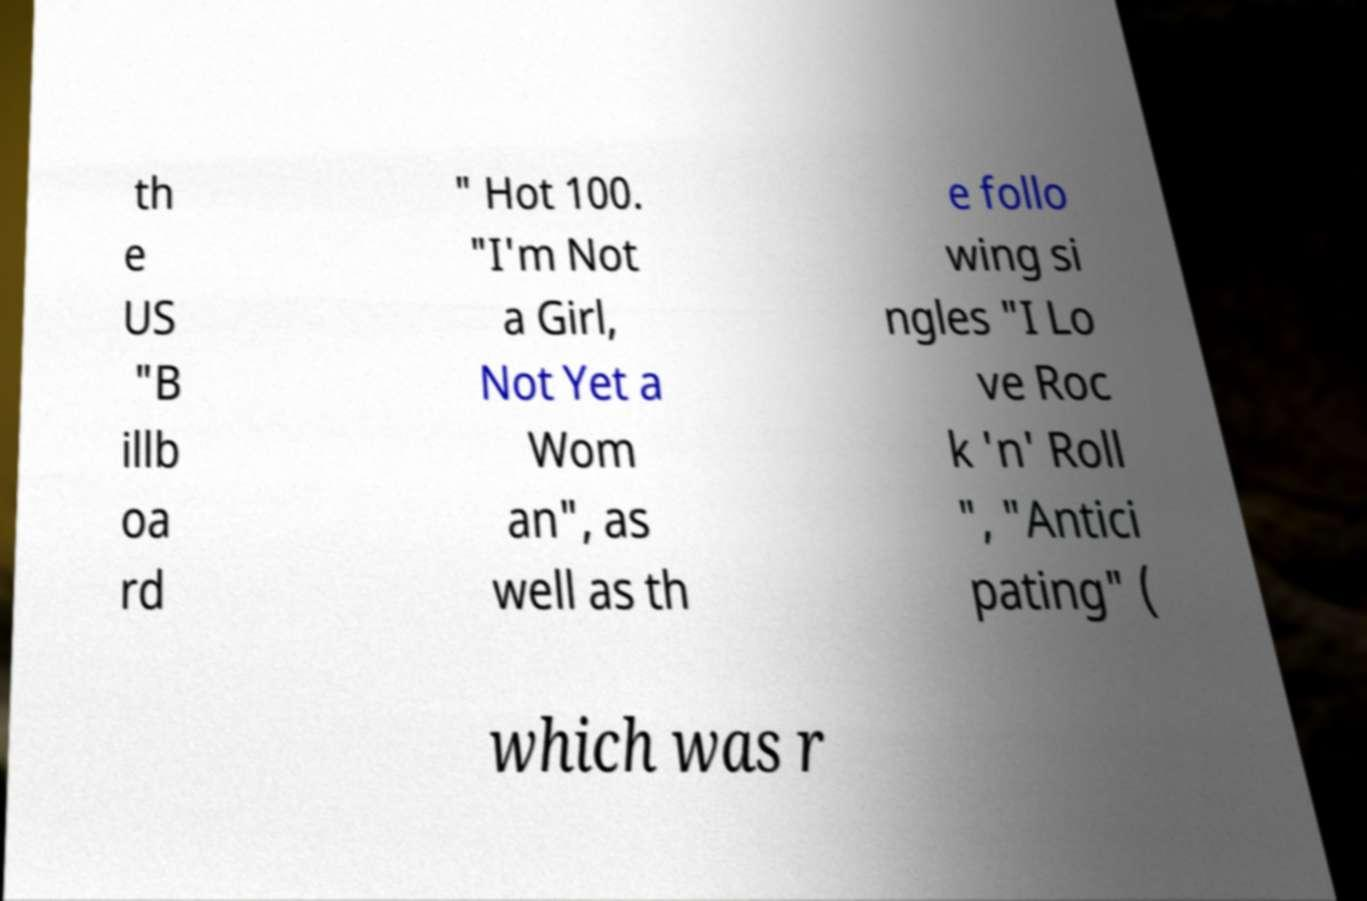I need the written content from this picture converted into text. Can you do that? th e US "B illb oa rd " Hot 100. "I'm Not a Girl, Not Yet a Wom an", as well as th e follo wing si ngles "I Lo ve Roc k 'n' Roll ", "Antici pating" ( which was r 